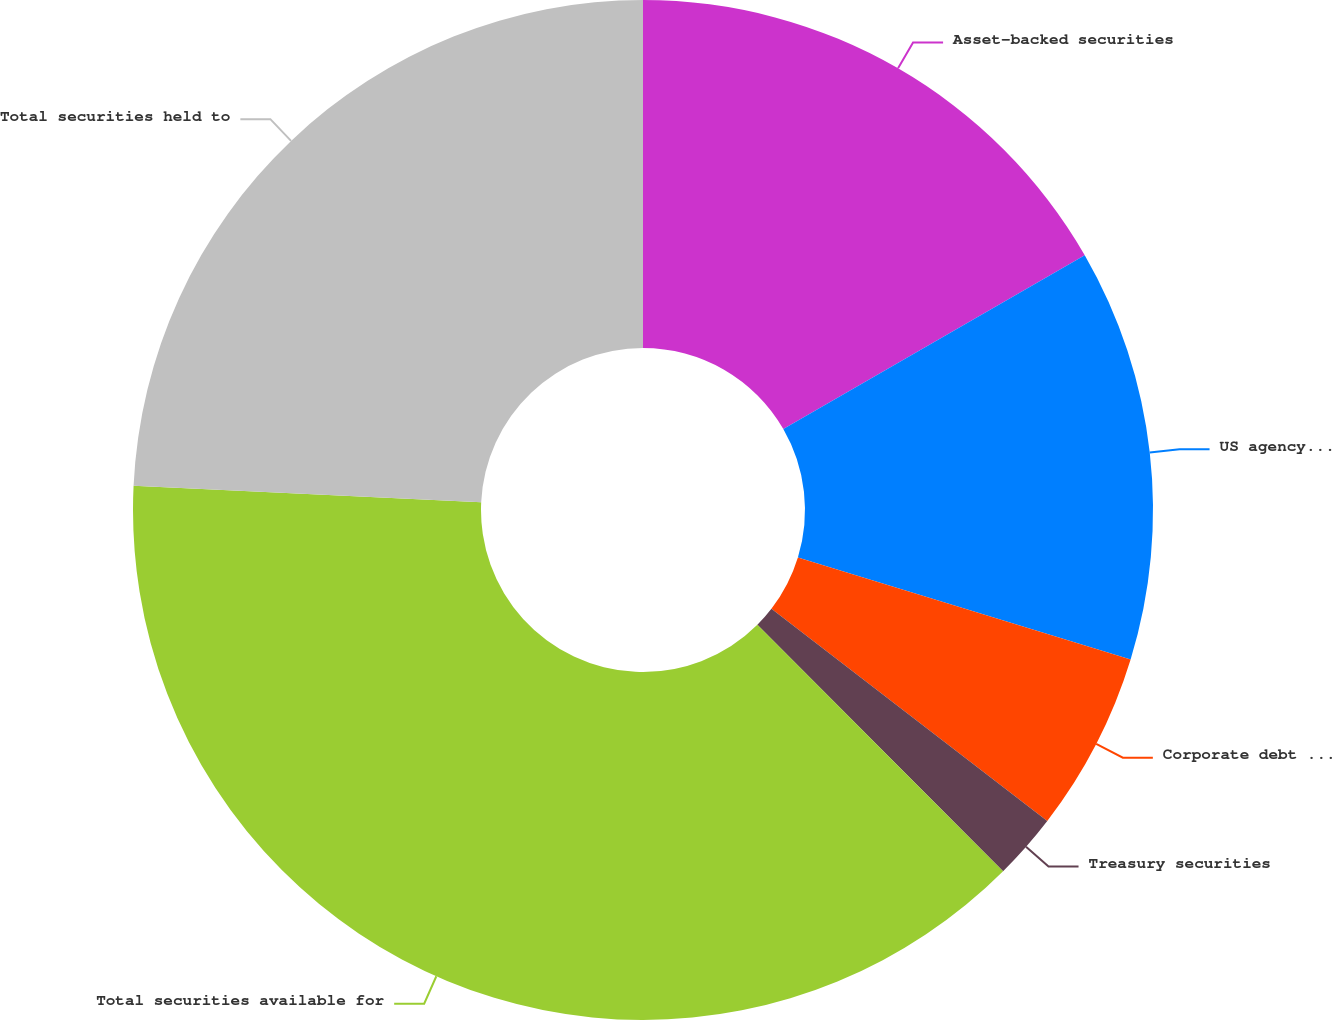Convert chart. <chart><loc_0><loc_0><loc_500><loc_500><pie_chart><fcel>Asset-backed securities<fcel>US agency mortgage-backed<fcel>Corporate debt securities<fcel>Treasury securities<fcel>Total securities available for<fcel>Total securities held to<nl><fcel>16.67%<fcel>13.06%<fcel>5.7%<fcel>2.09%<fcel>38.23%<fcel>24.24%<nl></chart> 